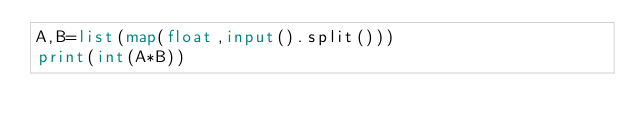Convert code to text. <code><loc_0><loc_0><loc_500><loc_500><_Python_>A,B=list(map(float,input().split()))
print(int(A*B))</code> 